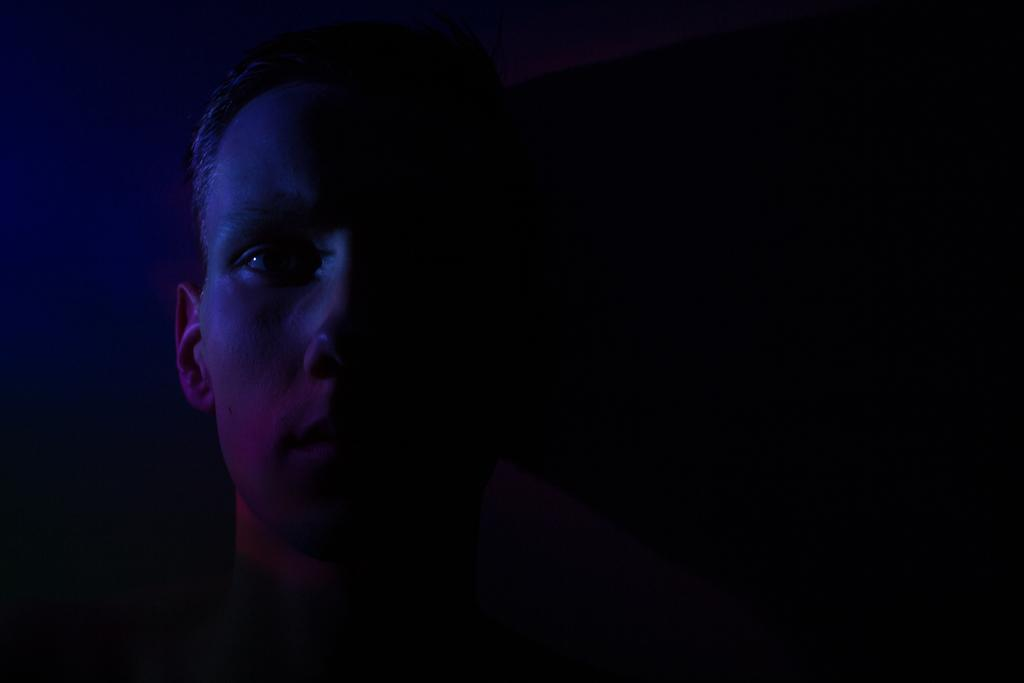Who is present in the image? There is a man in the image. Where is the man located in the image? The man is at the bottom of the image. What can be observed about the background of the image? The background of the image is dark. What type of religious ceremony is taking place in the image? There is no indication of a religious ceremony in the image; it only features a man at the bottom of the image with a dark background. 